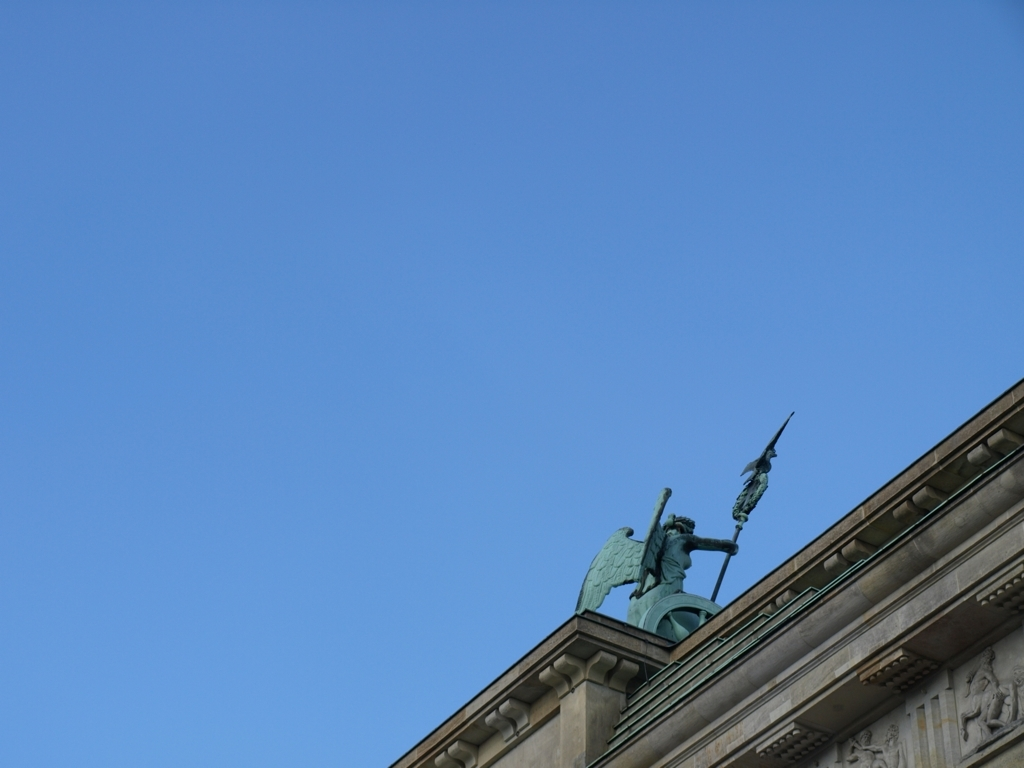Is the shooting angle ideal for this image? While the shooting angle captures the subject in a distinctive manner, providing a specific perspective of the statue against the sky, it could be further optimized for a more balanced composition or to include additional context that might offer a richer narrative about the location or significance of the statue. 